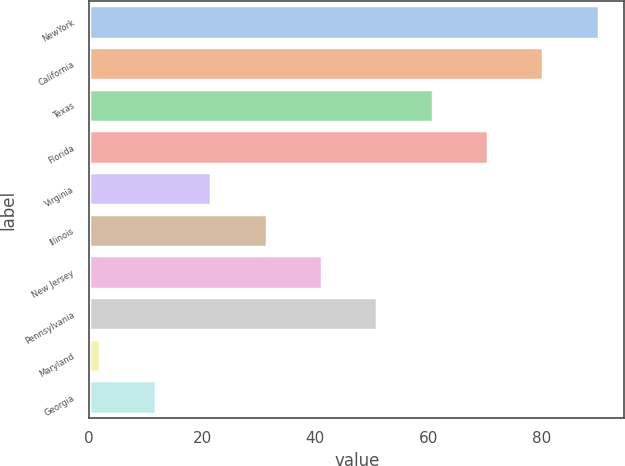Convert chart to OTSL. <chart><loc_0><loc_0><loc_500><loc_500><bar_chart><fcel>NewYork<fcel>California<fcel>Texas<fcel>Florida<fcel>Virginia<fcel>Illinois<fcel>New Jersey<fcel>Pennsylvania<fcel>Maryland<fcel>Georgia<nl><fcel>90.2<fcel>80.4<fcel>60.8<fcel>70.6<fcel>21.6<fcel>31.4<fcel>41.2<fcel>51<fcel>2<fcel>11.8<nl></chart> 